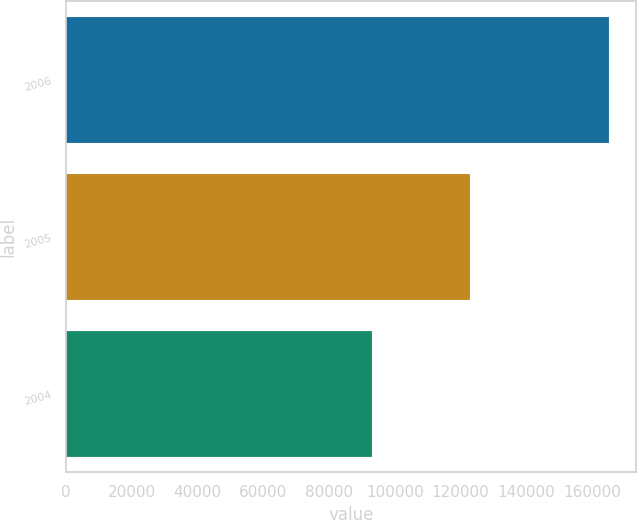<chart> <loc_0><loc_0><loc_500><loc_500><bar_chart><fcel>2006<fcel>2005<fcel>2004<nl><fcel>165100<fcel>122810<fcel>93100<nl></chart> 